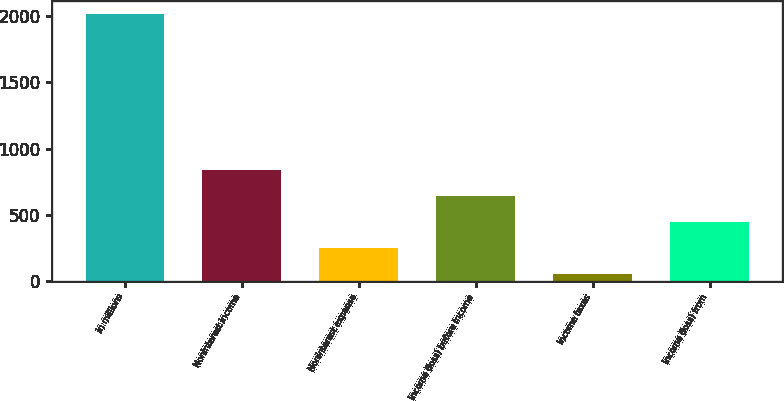Convert chart to OTSL. <chart><loc_0><loc_0><loc_500><loc_500><bar_chart><fcel>in millions<fcel>Noninterest income<fcel>Noninterest expense<fcel>Income (loss) before income<fcel>Income taxes<fcel>Income (loss) from<nl><fcel>2013<fcel>837.6<fcel>249.9<fcel>641.7<fcel>54<fcel>445.8<nl></chart> 